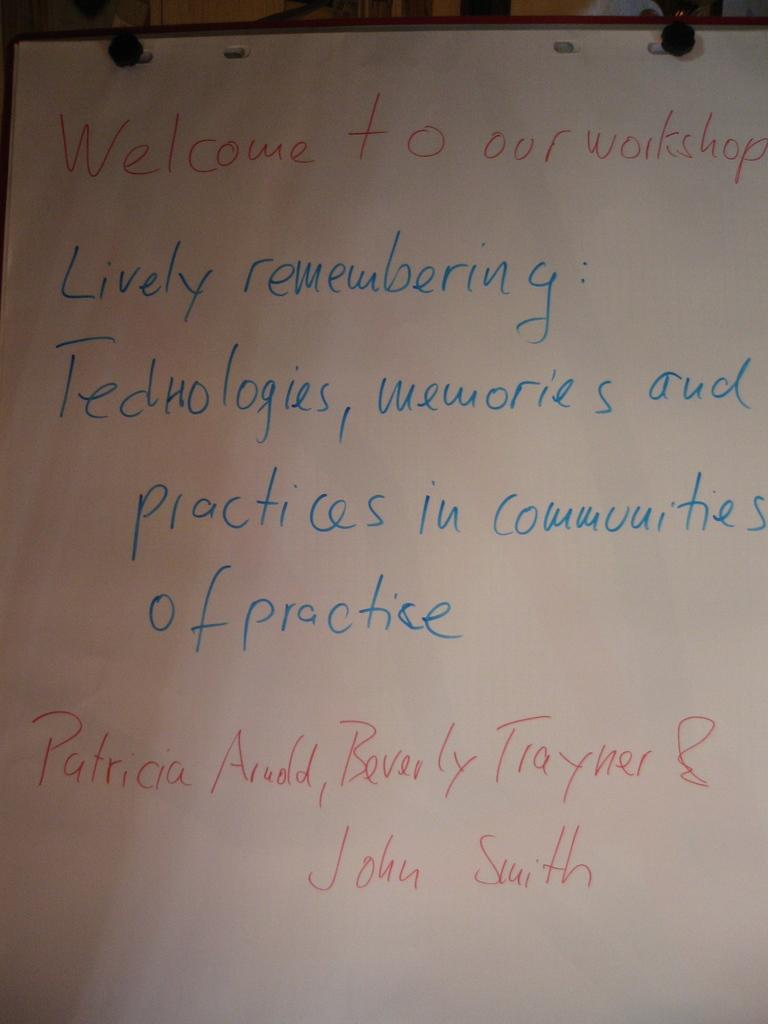<image>
Render a clear and concise summary of the photo. A board has writing that welcomes people to a workshop 